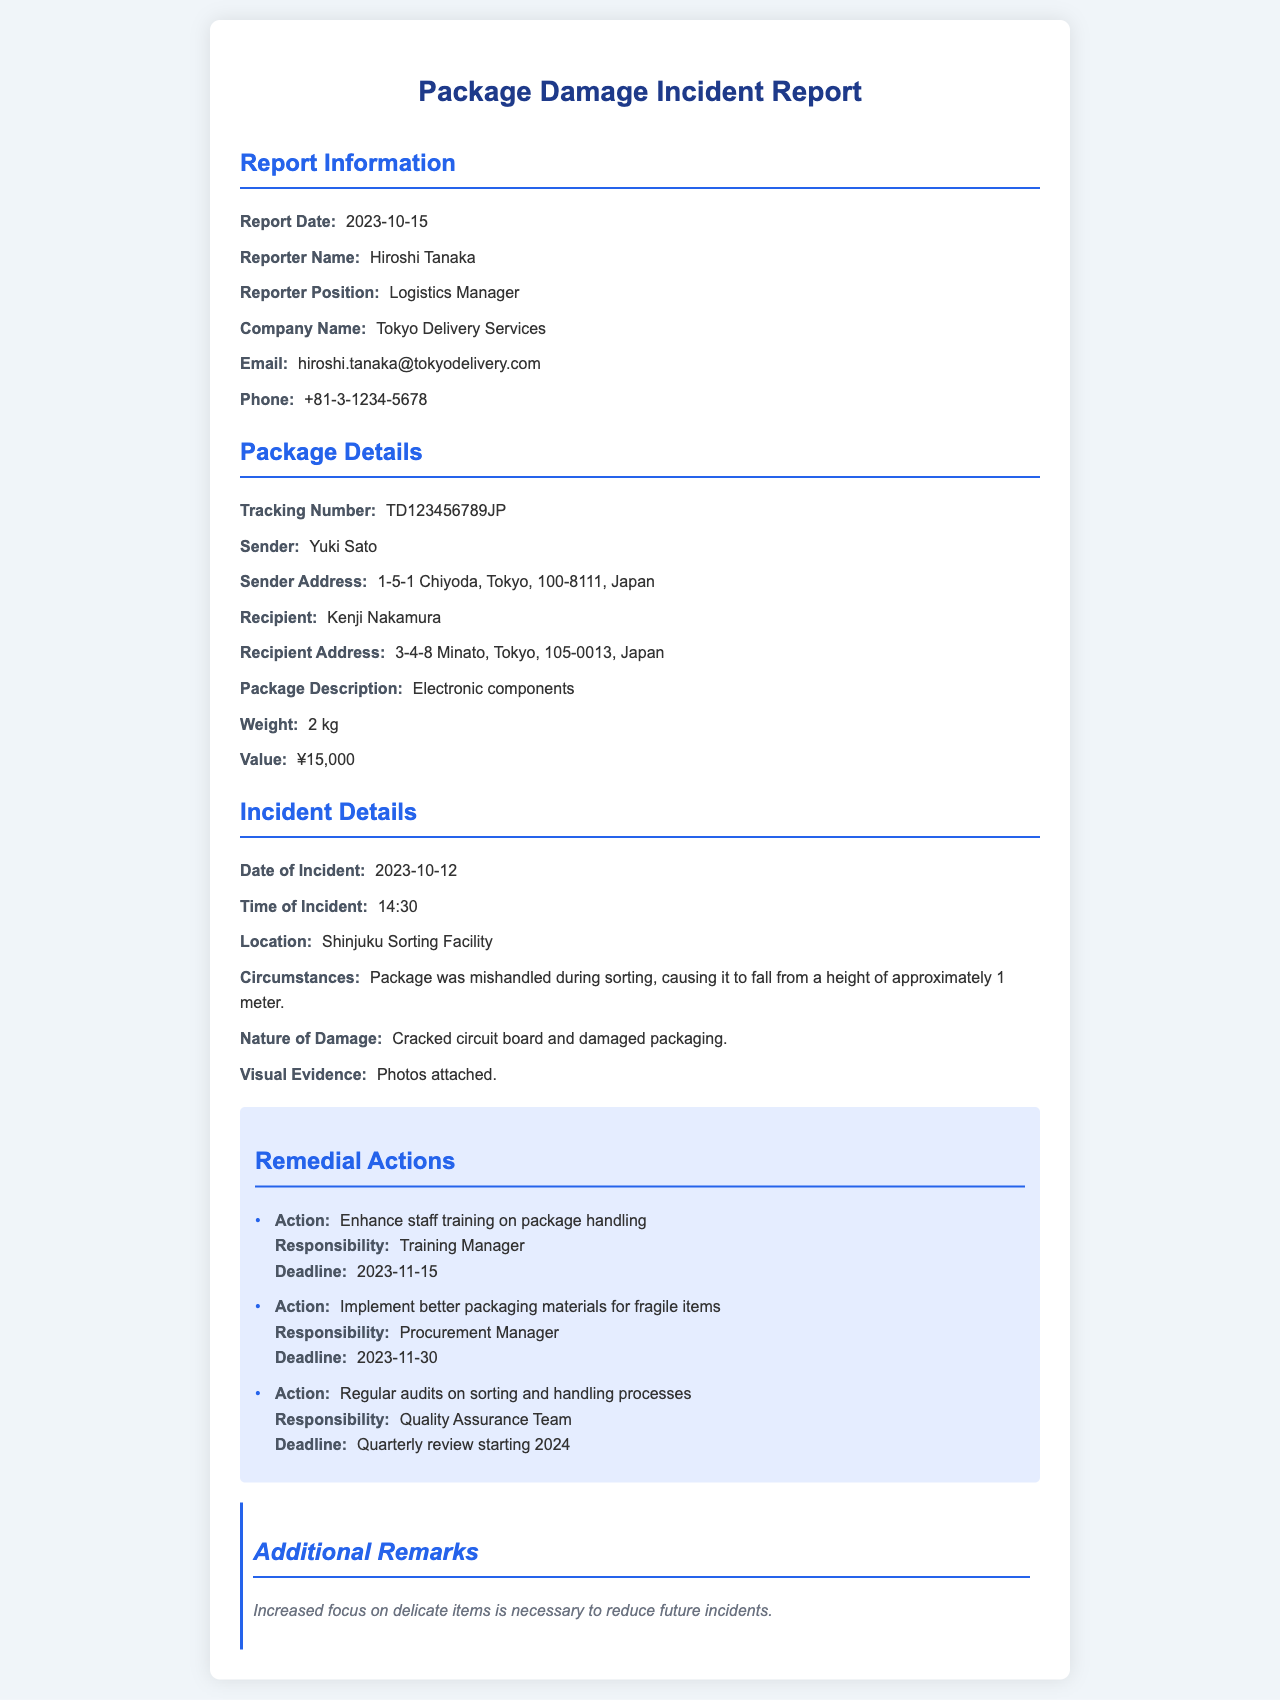What is the report date? The report date is stated clearly in the document under the Report Information section.
Answer: 2023-10-15 Who is the reporter? The reporter's name is found in the Report Information section, providing identification of the individual responsible for the report.
Answer: Hiroshi Tanaka What was the nature of the damage? The nature of the damage is described in the Incident Details section, capturing the specific problem that occurred.
Answer: Cracked circuit board and damaged packaging What time did the incident occur? The time of the incident is noted in the Incident Details section, indicating when the event took place.
Answer: 14:30 What remedial action is suggested for packaging materials? The suggested action regarding packaging materials is outlined in the Remedial Actions section of the document.
Answer: Implement better packaging materials for fragile items How many remedial actions are listed? The number of remedial actions can be counted in the Remedial Actions section, indicating the steps proposed to prevent future issues.
Answer: 3 What was the location of the incident? The location of the incident is specified in the Incident Details section, identifying where the damage occurred during transit.
Answer: Shinjuku Sorting Facility Who is responsible for enhancing staff training? Responsibility for the action related to staff training is provided in the Remedial Actions section, pinpointing the individual accountable.
Answer: Training Manager What is the value of the package? The package value is indicated in the Package Details section, representing its financial worth.
Answer: ¥15,000 What additional remarks were made? Additional remarks are included towards the end, summarizing the insights or suggestions following the incident report.
Answer: Increased focus on delicate items is necessary to reduce future incidents 